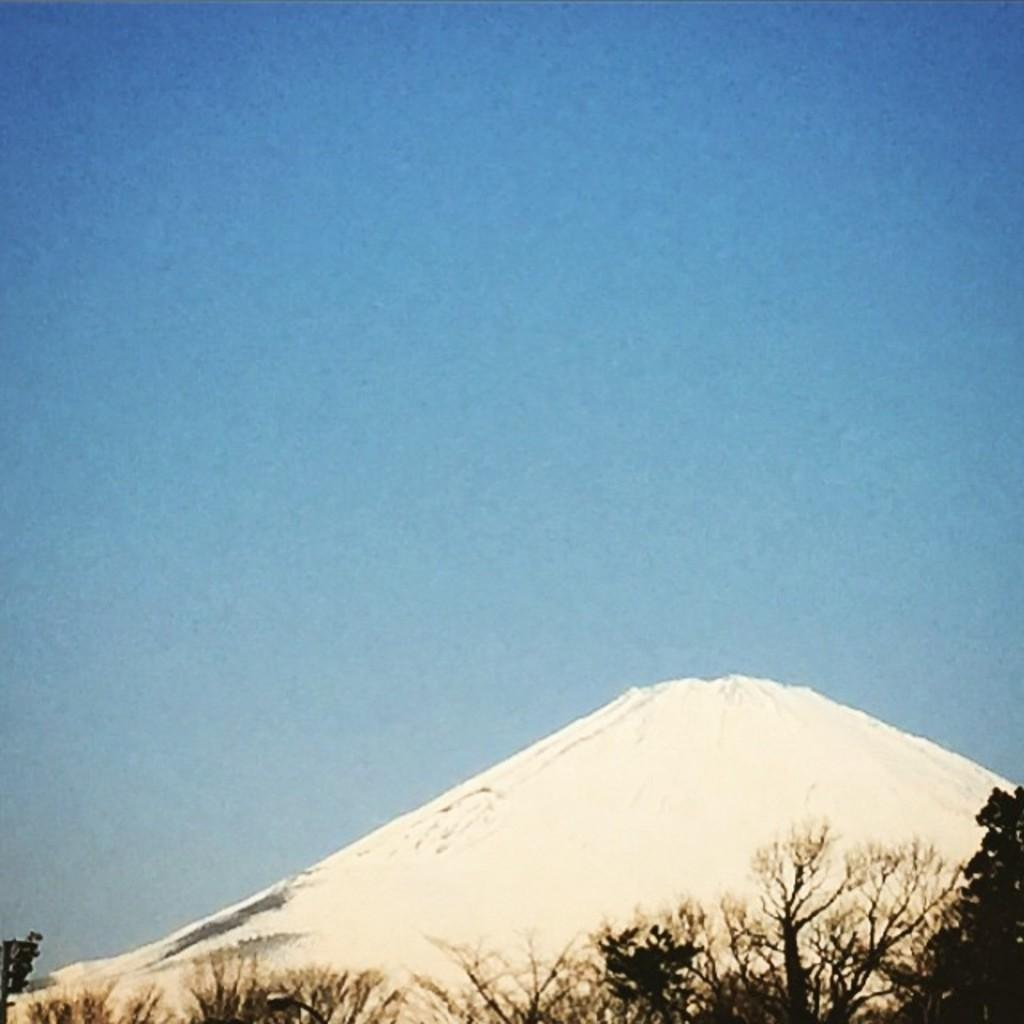What type of vegetation can be seen in the image? There are dried trees in the image. What is the color of the snow in the background? The snow in the background is white in color. What color is the sky in the image? The sky in the image is blue. What type of jam is being spread on the neck of the person in the image? There is no person or jam present in the image; it features dried trees and a blue sky. 